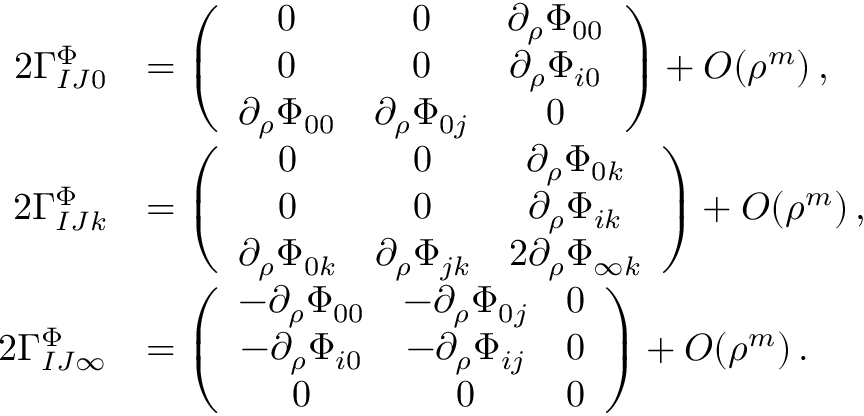Convert formula to latex. <formula><loc_0><loc_0><loc_500><loc_500>\begin{array} { r l } { 2 \Gamma _ { I J 0 } ^ { \Phi } } & { = \left ( \begin{array} { c c c } { 0 } & { 0 } & { \partial _ { \rho } \Phi _ { 0 0 } } \\ { 0 } & { 0 } & { \partial _ { \rho } \Phi _ { i 0 } } \\ { \partial _ { \rho } \Phi _ { 0 0 } } & { \partial _ { \rho } \Phi _ { 0 j } } & { 0 } \end{array} \right ) + O ( \rho ^ { m } ) \, , } \\ { 2 \Gamma _ { I J k } ^ { \Phi } } & { = \left ( \begin{array} { c c c } { 0 } & { 0 } & { \partial _ { \rho } \Phi _ { 0 k } } \\ { 0 } & { 0 } & { \partial _ { \rho } \Phi _ { i k } } \\ { \partial _ { \rho } \Phi _ { 0 k } } & { \partial _ { \rho } \Phi _ { j k } } & { 2 \partial _ { \rho } \Phi _ { \infty k } } \end{array} \right ) + O ( \rho ^ { m } ) \, , } \\ { 2 \Gamma _ { I J \infty } ^ { \Phi } } & { = \left ( \begin{array} { c c c } { - \partial _ { \rho } \Phi _ { 0 0 } } & { - \partial _ { \rho } \Phi _ { 0 j } } & { 0 } \\ { - \partial _ { \rho } \Phi _ { i 0 } } & { - \partial _ { \rho } \Phi _ { i j } } & { 0 } \\ { 0 } & { 0 } & { 0 } \end{array} \right ) + O ( \rho ^ { m } ) \, . } \end{array}</formula> 